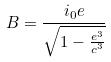Convert formula to latex. <formula><loc_0><loc_0><loc_500><loc_500>B = \frac { i _ { 0 } e } { \sqrt { 1 - \frac { e ^ { 3 } } { c ^ { 3 } } } }</formula> 